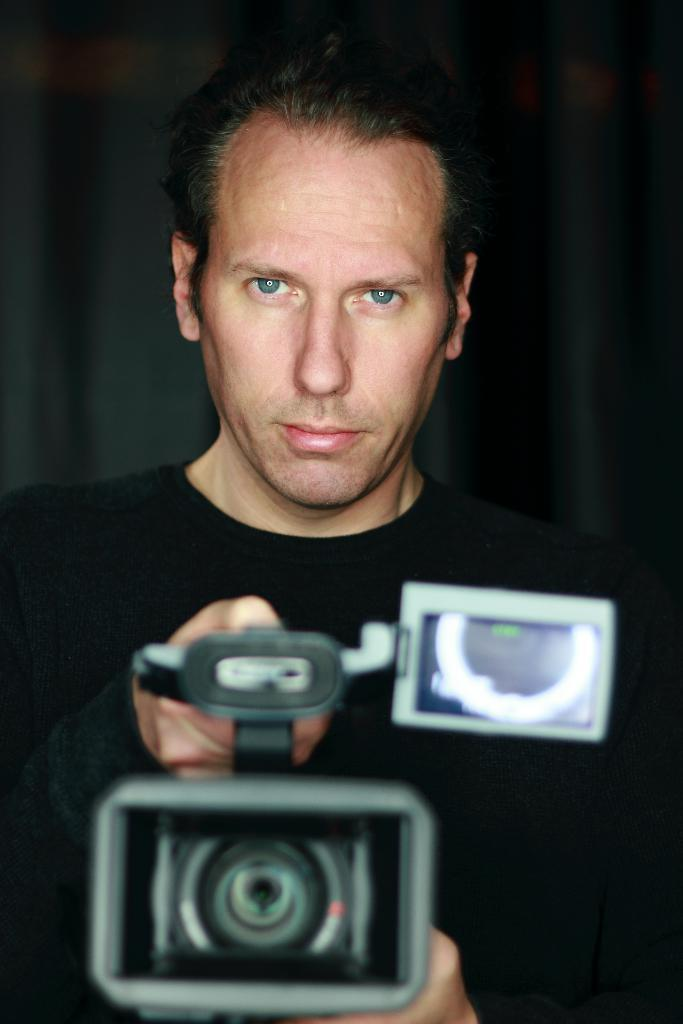Who is present in the image? There is a person in the image. What is the person doing in the image? The person is standing. What is the person wearing in the image? The person is wearing a black color shirt. What object is the person holding in the image? The person is holding a video camera in his hand. Can you see any goats in the image? No, there are no goats present in the image. What type of trade is being conducted in the image? There is no trade being conducted in the image; it features a person holding a video camera. 